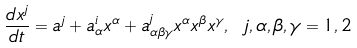<formula> <loc_0><loc_0><loc_500><loc_500>\frac { d x ^ { j } } { d t } = a ^ { j } + a _ { \alpha } ^ { i } x ^ { \alpha } + a _ { \alpha \beta \gamma } ^ { j } x ^ { \alpha } x ^ { \beta } x ^ { \gamma } , \ j , \alpha , \beta , \gamma = 1 , 2</formula> 